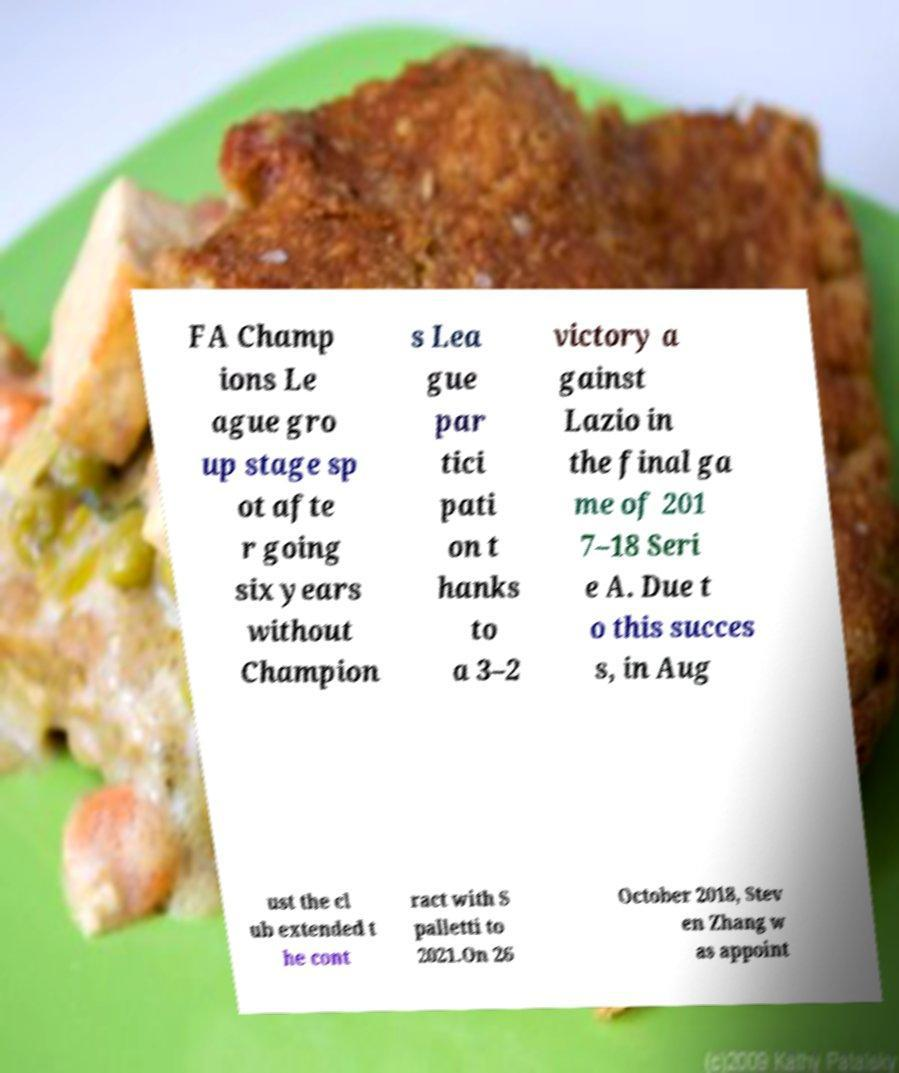Could you extract and type out the text from this image? FA Champ ions Le ague gro up stage sp ot afte r going six years without Champion s Lea gue par tici pati on t hanks to a 3–2 victory a gainst Lazio in the final ga me of 201 7–18 Seri e A. Due t o this succes s, in Aug ust the cl ub extended t he cont ract with S palletti to 2021.On 26 October 2018, Stev en Zhang w as appoint 